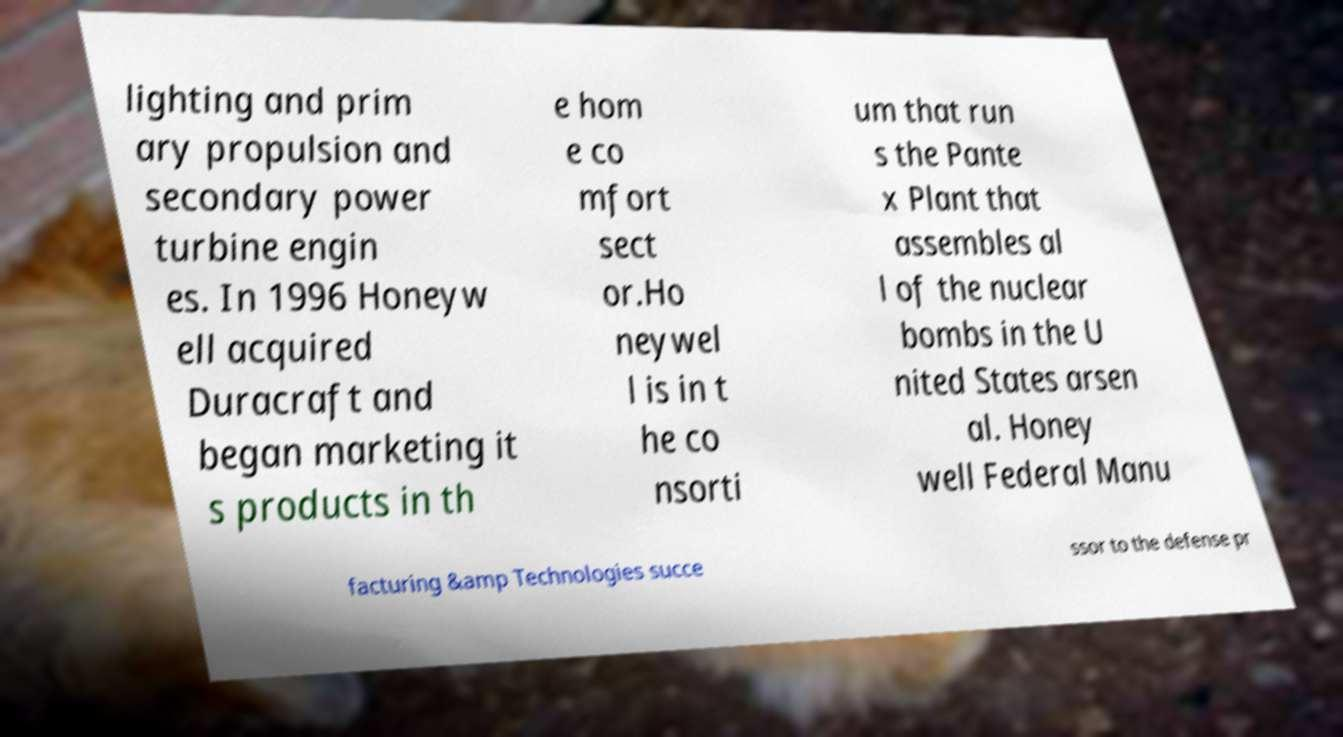Could you extract and type out the text from this image? lighting and prim ary propulsion and secondary power turbine engin es. In 1996 Honeyw ell acquired Duracraft and began marketing it s products in th e hom e co mfort sect or.Ho neywel l is in t he co nsorti um that run s the Pante x Plant that assembles al l of the nuclear bombs in the U nited States arsen al. Honey well Federal Manu facturing &amp Technologies succe ssor to the defense pr 